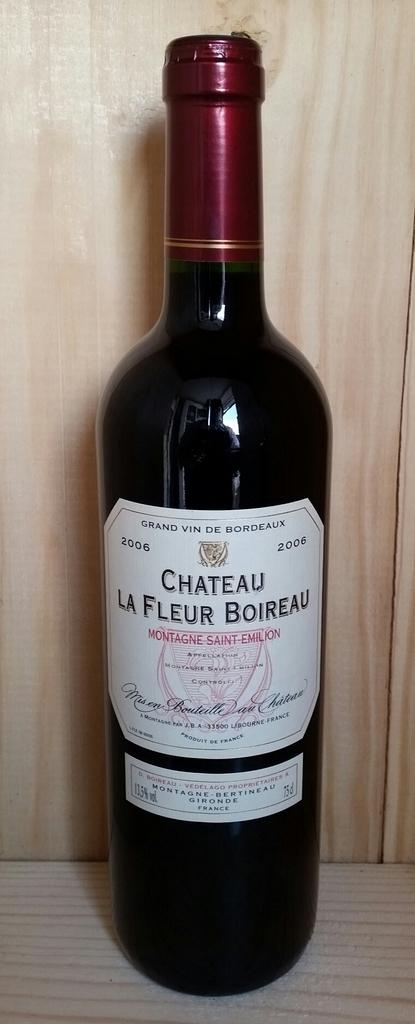<image>
Share a concise interpretation of the image provided. A bottle has a white label and is dated with the year 2006. 